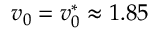Convert formula to latex. <formula><loc_0><loc_0><loc_500><loc_500>v _ { 0 } = v _ { 0 } ^ { * } \approx 1 . 8 5</formula> 